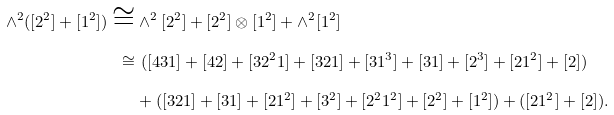Convert formula to latex. <formula><loc_0><loc_0><loc_500><loc_500>\wedge ^ { 2 } ( [ 2 ^ { 2 } ] + [ 1 ^ { 2 } ] ) \cong & \wedge ^ { 2 } [ 2 ^ { 2 } ] + [ 2 ^ { 2 } ] \otimes [ 1 ^ { 2 } ] + \wedge ^ { 2 } [ 1 ^ { 2 } ] \\ \cong & \ ( [ 4 3 1 ] + [ 4 2 ] + [ 3 2 ^ { 2 } 1 ] + [ 3 2 1 ] + [ 3 1 ^ { 3 } ] + [ 3 1 ] + [ 2 ^ { 3 } ] + [ 2 1 ^ { 2 } ] + [ 2 ] ) \\ & + ( [ 3 2 1 ] + [ 3 1 ] + [ 2 1 ^ { 2 } ] + [ 3 ^ { 2 } ] + [ 2 ^ { 2 } 1 ^ { 2 } ] + [ 2 ^ { 2 } ] + [ 1 ^ { 2 } ] ) + ( [ 2 1 ^ { 2 } ] + [ 2 ] ) .</formula> 